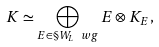Convert formula to latex. <formula><loc_0><loc_0><loc_500><loc_500>K \simeq \bigoplus _ { E \in \S W _ { L } \ w g } E \otimes K _ { E } ,</formula> 